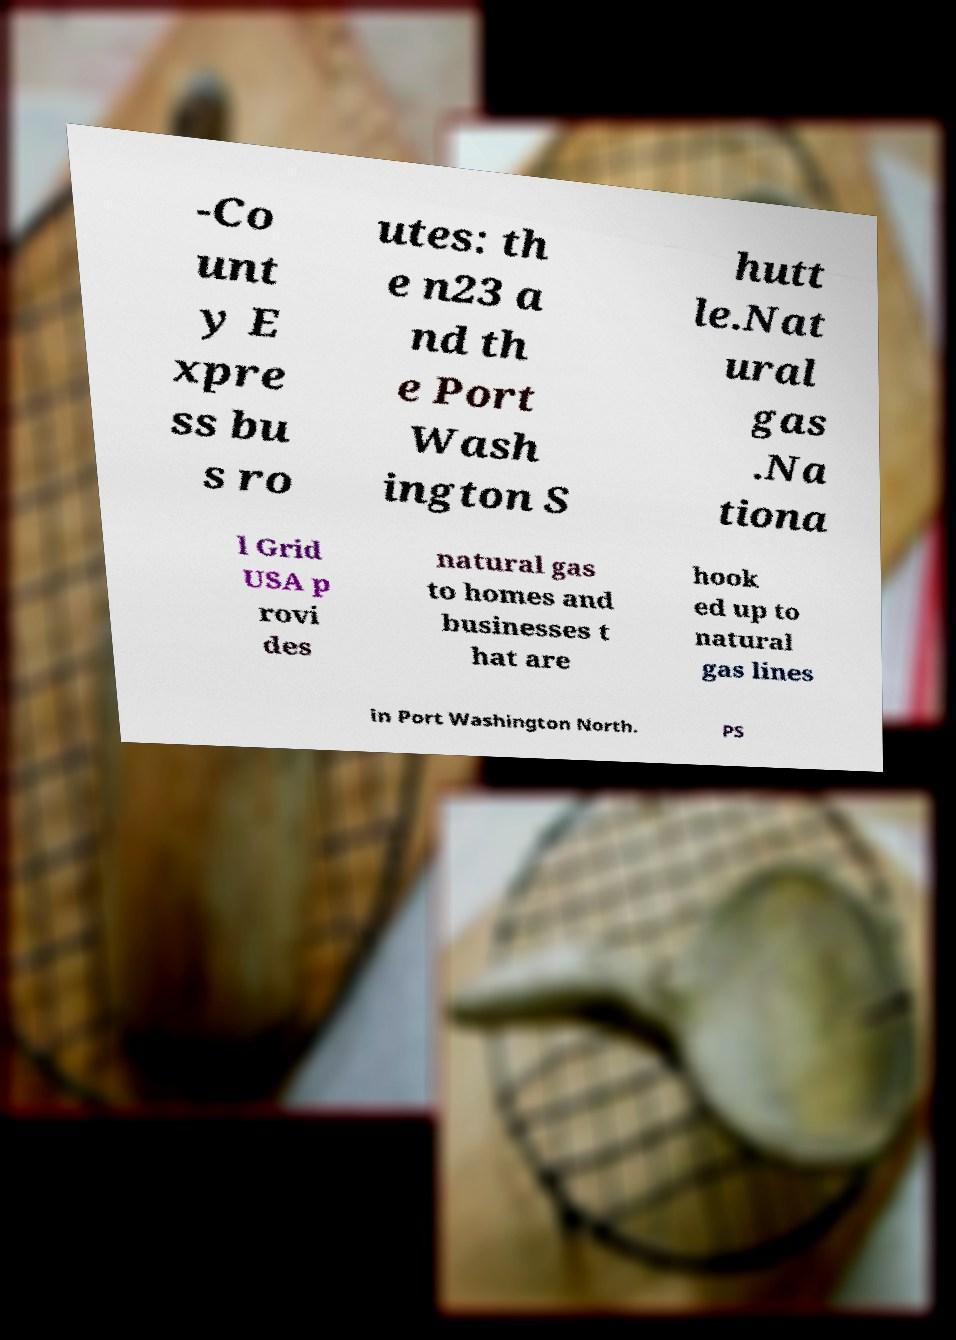For documentation purposes, I need the text within this image transcribed. Could you provide that? -Co unt y E xpre ss bu s ro utes: th e n23 a nd th e Port Wash ington S hutt le.Nat ural gas .Na tiona l Grid USA p rovi des natural gas to homes and businesses t hat are hook ed up to natural gas lines in Port Washington North. PS 